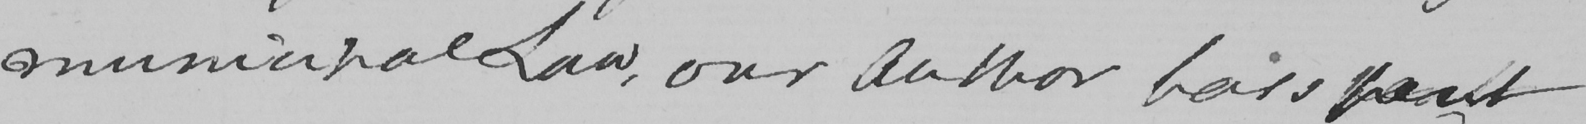Can you read and transcribe this handwriting? municipal Law, our Author has spent 